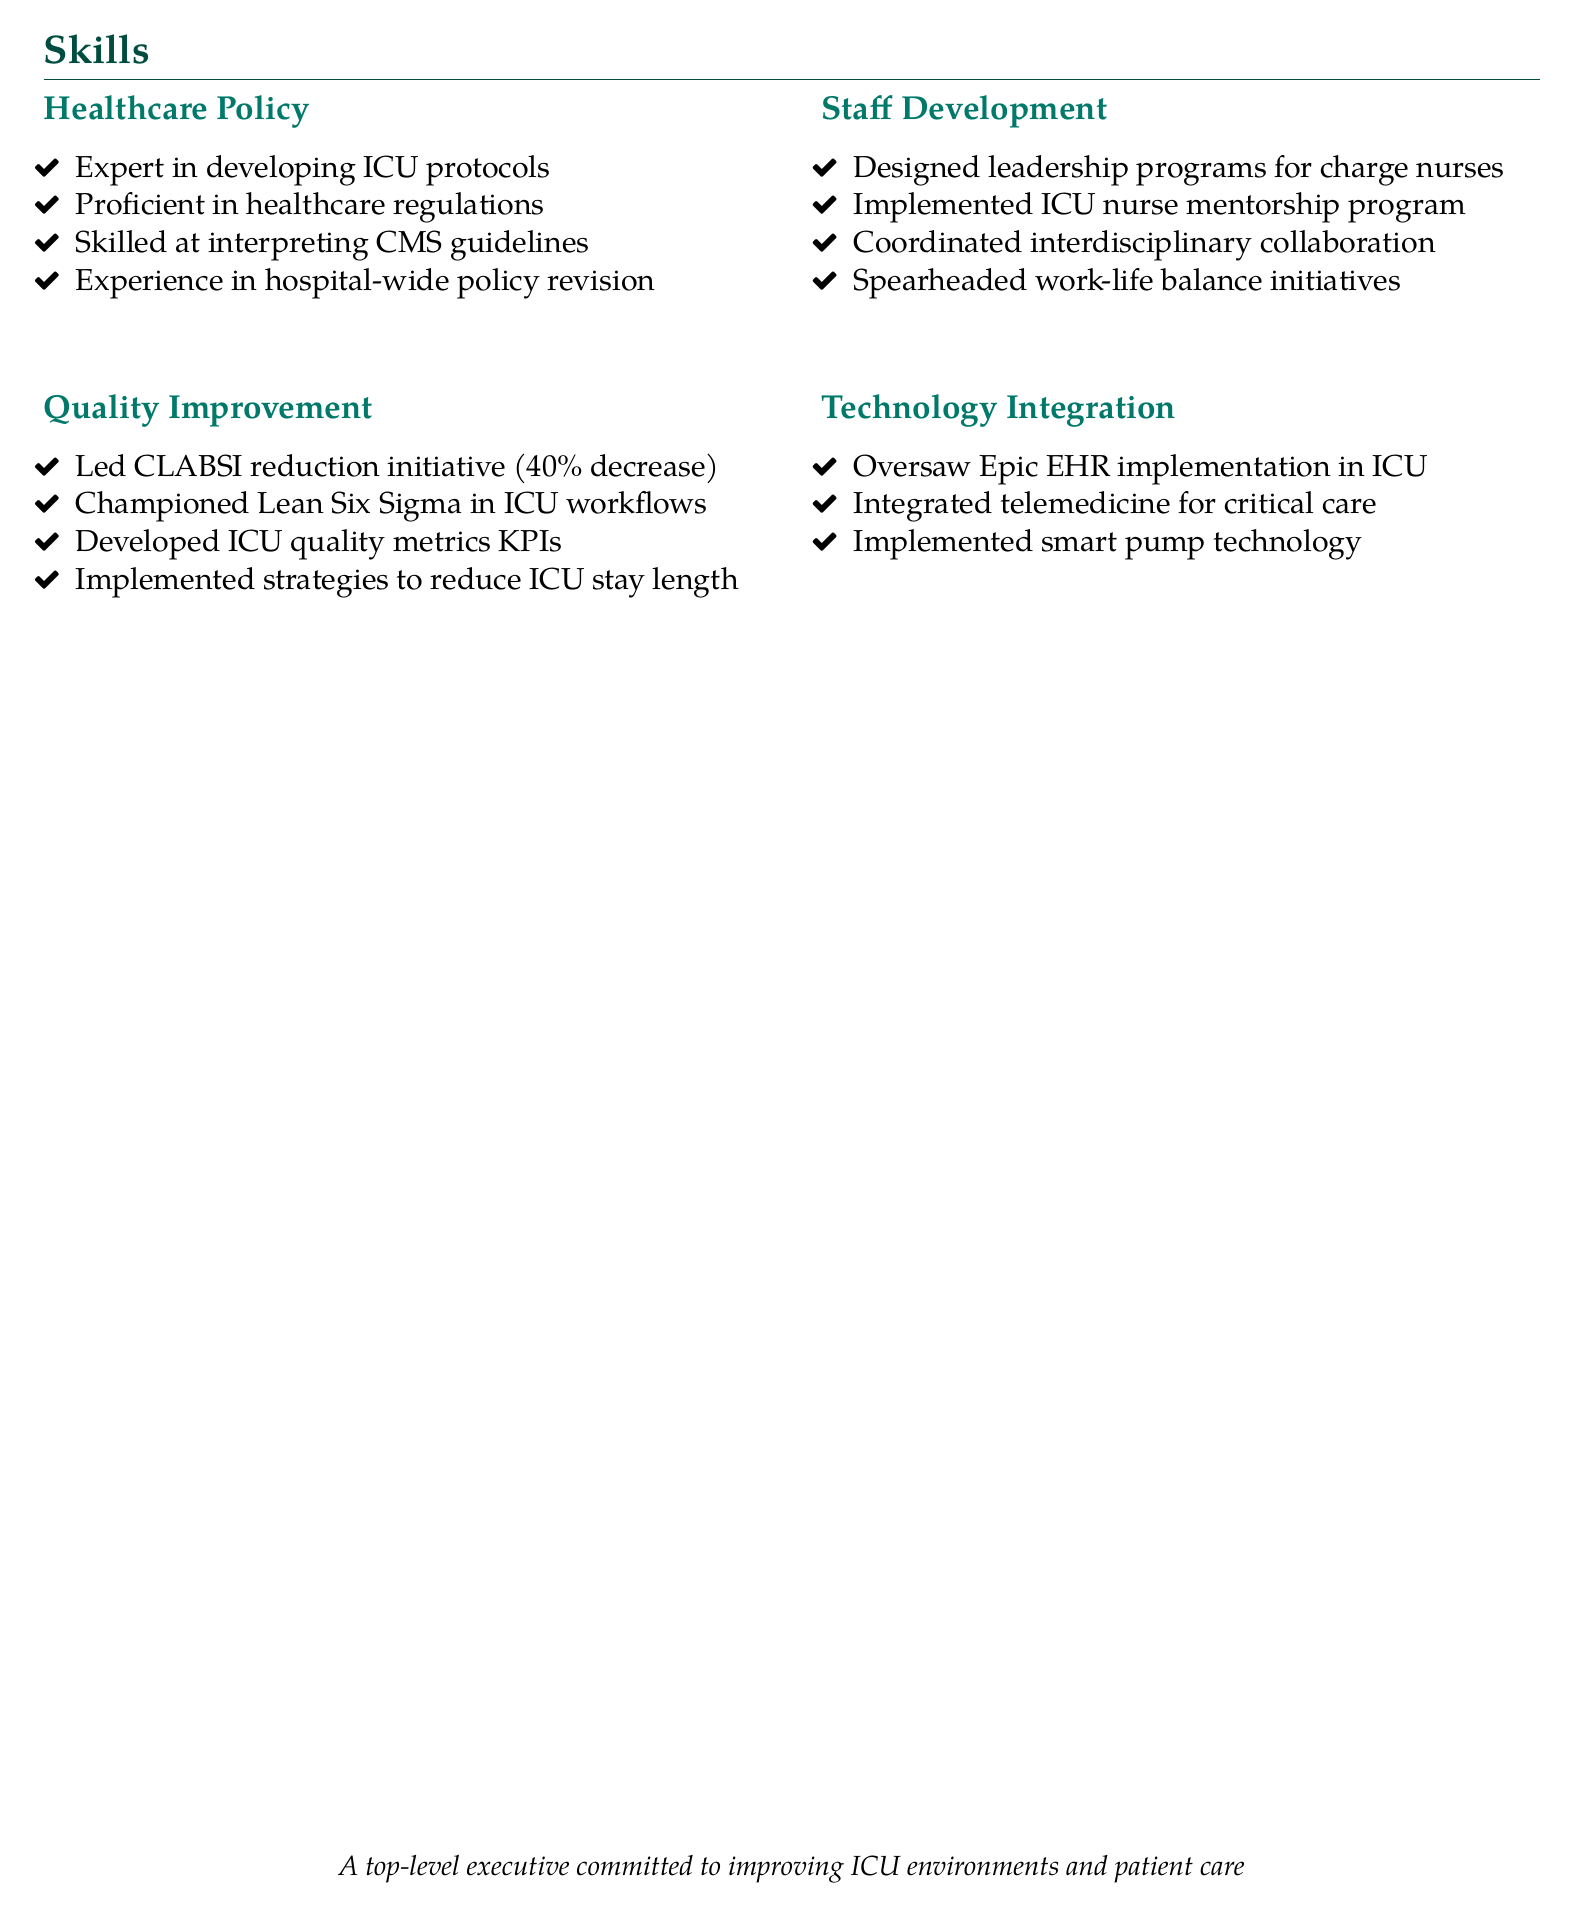What is one expertise in healthcare policy? The document lists several areas of expertise, one of which is the development and implementation of evidence-based ICU protocols.
Answer: Developing ICU protocols What percentage decrease in infection rates was achieved in the CLABSI reduction initiative? The resume states that the CLABSI reduction initiative led to a 40% decrease in infection rates.
Answer: 40% What is a key focus of the staff development section? The staff development section mentions implementing a mentorship program for new ICU nurses, which is a key focus.
Answer: Mentorship program What technology was implemented to improve medication safety? The resume mentions that smart pump technology was implemented to improve medication safety in the ICU.
Answer: Smart pump technology What methodology was championed to streamline ICU workflows? The document highlights the use of Lean Six Sigma methodologies as a means to streamline ICU workflows.
Answer: Lean Six Sigma How many subsections are there in the skills section of the resume? There are four specified subsections in the skills section: Healthcare Policy, Quality Improvement, Staff Development, and Technology Integration.
Answer: Four What does the document suggest about initiatives related to work-life balance? The resume indicates that there were initiatives spearheaded to promote work-life balance and reduce nurse burnout.
Answer: Promote work-life balance Who led the implementation of the nurse mentorship program? The document indicates that the individual who designed and implemented the mentorship program was responsible for this initiative, suggesting a leadership role.
Answer: Designed and implemented by the individual 